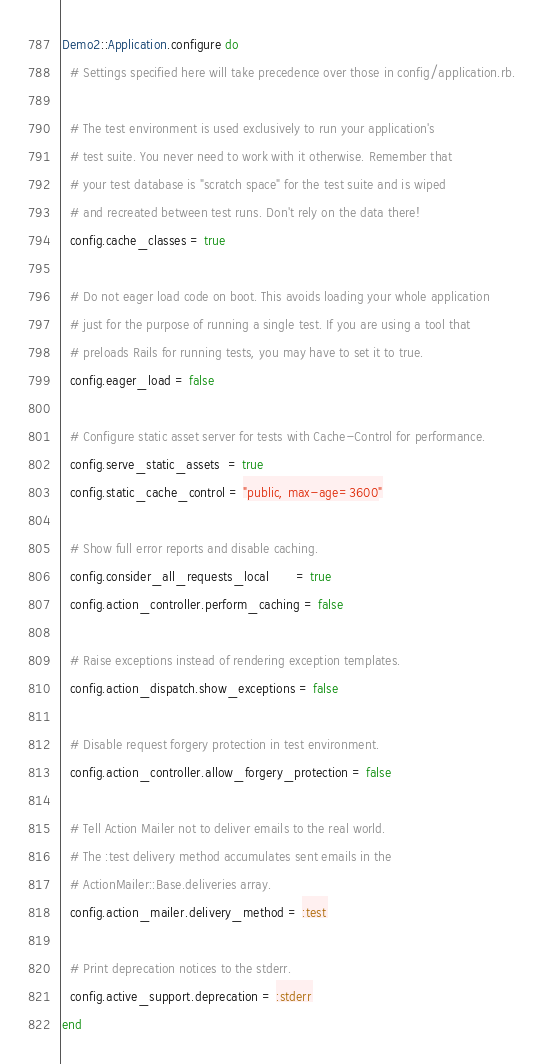<code> <loc_0><loc_0><loc_500><loc_500><_Ruby_>Demo2::Application.configure do
  # Settings specified here will take precedence over those in config/application.rb.

  # The test environment is used exclusively to run your application's
  # test suite. You never need to work with it otherwise. Remember that
  # your test database is "scratch space" for the test suite and is wiped
  # and recreated between test runs. Don't rely on the data there!
  config.cache_classes = true

  # Do not eager load code on boot. This avoids loading your whole application
  # just for the purpose of running a single test. If you are using a tool that
  # preloads Rails for running tests, you may have to set it to true.
  config.eager_load = false

  # Configure static asset server for tests with Cache-Control for performance.
  config.serve_static_assets  = true
  config.static_cache_control = "public, max-age=3600"

  # Show full error reports and disable caching.
  config.consider_all_requests_local       = true
  config.action_controller.perform_caching = false

  # Raise exceptions instead of rendering exception templates.
  config.action_dispatch.show_exceptions = false

  # Disable request forgery protection in test environment.
  config.action_controller.allow_forgery_protection = false

  # Tell Action Mailer not to deliver emails to the real world.
  # The :test delivery method accumulates sent emails in the
  # ActionMailer::Base.deliveries array.
  config.action_mailer.delivery_method = :test

  # Print deprecation notices to the stderr.
  config.active_support.deprecation = :stderr
end
</code> 